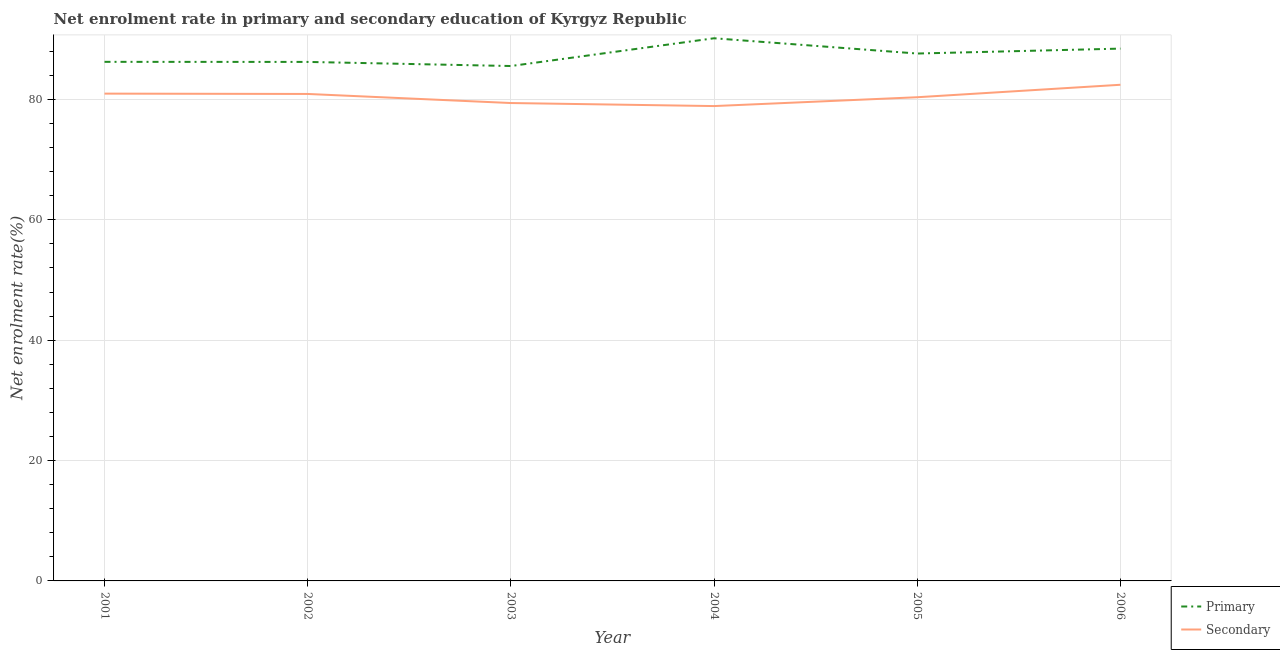Does the line corresponding to enrollment rate in primary education intersect with the line corresponding to enrollment rate in secondary education?
Your answer should be compact. No. What is the enrollment rate in secondary education in 2005?
Ensure brevity in your answer.  80.37. Across all years, what is the maximum enrollment rate in primary education?
Your response must be concise. 90.17. Across all years, what is the minimum enrollment rate in primary education?
Offer a terse response. 85.56. In which year was the enrollment rate in primary education maximum?
Make the answer very short. 2004. What is the total enrollment rate in primary education in the graph?
Give a very brief answer. 524.32. What is the difference between the enrollment rate in secondary education in 2001 and that in 2004?
Your answer should be compact. 2.07. What is the difference between the enrollment rate in secondary education in 2004 and the enrollment rate in primary education in 2003?
Your response must be concise. -6.65. What is the average enrollment rate in primary education per year?
Give a very brief answer. 87.39. In the year 2001, what is the difference between the enrollment rate in primary education and enrollment rate in secondary education?
Ensure brevity in your answer.  5.28. What is the ratio of the enrollment rate in secondary education in 2002 to that in 2003?
Your answer should be very brief. 1.02. What is the difference between the highest and the second highest enrollment rate in secondary education?
Provide a succinct answer. 1.47. What is the difference between the highest and the lowest enrollment rate in secondary education?
Your answer should be compact. 3.54. How many lines are there?
Provide a short and direct response. 2. Does the graph contain grids?
Keep it short and to the point. Yes. How many legend labels are there?
Provide a succinct answer. 2. How are the legend labels stacked?
Ensure brevity in your answer.  Vertical. What is the title of the graph?
Your response must be concise. Net enrolment rate in primary and secondary education of Kyrgyz Republic. Does "Mineral" appear as one of the legend labels in the graph?
Provide a short and direct response. No. What is the label or title of the X-axis?
Offer a terse response. Year. What is the label or title of the Y-axis?
Ensure brevity in your answer.  Net enrolment rate(%). What is the Net enrolment rate(%) in Primary in 2001?
Your answer should be compact. 86.25. What is the Net enrolment rate(%) in Secondary in 2001?
Ensure brevity in your answer.  80.97. What is the Net enrolment rate(%) in Primary in 2002?
Your answer should be compact. 86.24. What is the Net enrolment rate(%) in Secondary in 2002?
Ensure brevity in your answer.  80.92. What is the Net enrolment rate(%) of Primary in 2003?
Provide a short and direct response. 85.56. What is the Net enrolment rate(%) in Secondary in 2003?
Ensure brevity in your answer.  79.41. What is the Net enrolment rate(%) of Primary in 2004?
Provide a short and direct response. 90.17. What is the Net enrolment rate(%) of Secondary in 2004?
Keep it short and to the point. 78.91. What is the Net enrolment rate(%) in Primary in 2005?
Provide a short and direct response. 87.64. What is the Net enrolment rate(%) in Secondary in 2005?
Keep it short and to the point. 80.37. What is the Net enrolment rate(%) in Primary in 2006?
Your answer should be compact. 88.45. What is the Net enrolment rate(%) in Secondary in 2006?
Offer a very short reply. 82.45. Across all years, what is the maximum Net enrolment rate(%) in Primary?
Your response must be concise. 90.17. Across all years, what is the maximum Net enrolment rate(%) in Secondary?
Your answer should be compact. 82.45. Across all years, what is the minimum Net enrolment rate(%) of Primary?
Make the answer very short. 85.56. Across all years, what is the minimum Net enrolment rate(%) in Secondary?
Make the answer very short. 78.91. What is the total Net enrolment rate(%) in Primary in the graph?
Make the answer very short. 524.32. What is the total Net enrolment rate(%) in Secondary in the graph?
Make the answer very short. 483.03. What is the difference between the Net enrolment rate(%) in Primary in 2001 and that in 2002?
Provide a succinct answer. 0.01. What is the difference between the Net enrolment rate(%) in Secondary in 2001 and that in 2002?
Offer a terse response. 0.05. What is the difference between the Net enrolment rate(%) in Primary in 2001 and that in 2003?
Keep it short and to the point. 0.7. What is the difference between the Net enrolment rate(%) of Secondary in 2001 and that in 2003?
Your response must be concise. 1.56. What is the difference between the Net enrolment rate(%) of Primary in 2001 and that in 2004?
Keep it short and to the point. -3.92. What is the difference between the Net enrolment rate(%) in Secondary in 2001 and that in 2004?
Offer a very short reply. 2.07. What is the difference between the Net enrolment rate(%) of Primary in 2001 and that in 2005?
Offer a terse response. -1.38. What is the difference between the Net enrolment rate(%) in Secondary in 2001 and that in 2005?
Offer a very short reply. 0.6. What is the difference between the Net enrolment rate(%) of Primary in 2001 and that in 2006?
Offer a very short reply. -2.2. What is the difference between the Net enrolment rate(%) in Secondary in 2001 and that in 2006?
Your answer should be very brief. -1.47. What is the difference between the Net enrolment rate(%) of Primary in 2002 and that in 2003?
Keep it short and to the point. 0.68. What is the difference between the Net enrolment rate(%) in Secondary in 2002 and that in 2003?
Your answer should be compact. 1.51. What is the difference between the Net enrolment rate(%) of Primary in 2002 and that in 2004?
Give a very brief answer. -3.93. What is the difference between the Net enrolment rate(%) in Secondary in 2002 and that in 2004?
Ensure brevity in your answer.  2.01. What is the difference between the Net enrolment rate(%) in Primary in 2002 and that in 2005?
Offer a very short reply. -1.39. What is the difference between the Net enrolment rate(%) of Secondary in 2002 and that in 2005?
Your answer should be very brief. 0.55. What is the difference between the Net enrolment rate(%) of Primary in 2002 and that in 2006?
Provide a succinct answer. -2.21. What is the difference between the Net enrolment rate(%) of Secondary in 2002 and that in 2006?
Give a very brief answer. -1.53. What is the difference between the Net enrolment rate(%) in Primary in 2003 and that in 2004?
Provide a succinct answer. -4.61. What is the difference between the Net enrolment rate(%) in Secondary in 2003 and that in 2004?
Ensure brevity in your answer.  0.51. What is the difference between the Net enrolment rate(%) of Primary in 2003 and that in 2005?
Offer a terse response. -2.08. What is the difference between the Net enrolment rate(%) in Secondary in 2003 and that in 2005?
Ensure brevity in your answer.  -0.96. What is the difference between the Net enrolment rate(%) of Primary in 2003 and that in 2006?
Your response must be concise. -2.89. What is the difference between the Net enrolment rate(%) of Secondary in 2003 and that in 2006?
Keep it short and to the point. -3.04. What is the difference between the Net enrolment rate(%) of Primary in 2004 and that in 2005?
Keep it short and to the point. 2.54. What is the difference between the Net enrolment rate(%) in Secondary in 2004 and that in 2005?
Keep it short and to the point. -1.47. What is the difference between the Net enrolment rate(%) of Primary in 2004 and that in 2006?
Your answer should be very brief. 1.72. What is the difference between the Net enrolment rate(%) in Secondary in 2004 and that in 2006?
Make the answer very short. -3.54. What is the difference between the Net enrolment rate(%) of Primary in 2005 and that in 2006?
Your answer should be compact. -0.82. What is the difference between the Net enrolment rate(%) in Secondary in 2005 and that in 2006?
Your answer should be compact. -2.07. What is the difference between the Net enrolment rate(%) in Primary in 2001 and the Net enrolment rate(%) in Secondary in 2002?
Offer a terse response. 5.34. What is the difference between the Net enrolment rate(%) of Primary in 2001 and the Net enrolment rate(%) of Secondary in 2003?
Give a very brief answer. 6.84. What is the difference between the Net enrolment rate(%) in Primary in 2001 and the Net enrolment rate(%) in Secondary in 2004?
Provide a succinct answer. 7.35. What is the difference between the Net enrolment rate(%) of Primary in 2001 and the Net enrolment rate(%) of Secondary in 2005?
Ensure brevity in your answer.  5.88. What is the difference between the Net enrolment rate(%) of Primary in 2001 and the Net enrolment rate(%) of Secondary in 2006?
Keep it short and to the point. 3.81. What is the difference between the Net enrolment rate(%) of Primary in 2002 and the Net enrolment rate(%) of Secondary in 2003?
Give a very brief answer. 6.83. What is the difference between the Net enrolment rate(%) in Primary in 2002 and the Net enrolment rate(%) in Secondary in 2004?
Provide a short and direct response. 7.34. What is the difference between the Net enrolment rate(%) of Primary in 2002 and the Net enrolment rate(%) of Secondary in 2005?
Provide a succinct answer. 5.87. What is the difference between the Net enrolment rate(%) in Primary in 2002 and the Net enrolment rate(%) in Secondary in 2006?
Provide a succinct answer. 3.8. What is the difference between the Net enrolment rate(%) of Primary in 2003 and the Net enrolment rate(%) of Secondary in 2004?
Provide a succinct answer. 6.65. What is the difference between the Net enrolment rate(%) in Primary in 2003 and the Net enrolment rate(%) in Secondary in 2005?
Provide a short and direct response. 5.19. What is the difference between the Net enrolment rate(%) in Primary in 2003 and the Net enrolment rate(%) in Secondary in 2006?
Offer a terse response. 3.11. What is the difference between the Net enrolment rate(%) in Primary in 2004 and the Net enrolment rate(%) in Secondary in 2005?
Provide a short and direct response. 9.8. What is the difference between the Net enrolment rate(%) of Primary in 2004 and the Net enrolment rate(%) of Secondary in 2006?
Give a very brief answer. 7.73. What is the difference between the Net enrolment rate(%) in Primary in 2005 and the Net enrolment rate(%) in Secondary in 2006?
Your answer should be compact. 5.19. What is the average Net enrolment rate(%) in Primary per year?
Keep it short and to the point. 87.39. What is the average Net enrolment rate(%) of Secondary per year?
Your response must be concise. 80.5. In the year 2001, what is the difference between the Net enrolment rate(%) in Primary and Net enrolment rate(%) in Secondary?
Your answer should be very brief. 5.28. In the year 2002, what is the difference between the Net enrolment rate(%) of Primary and Net enrolment rate(%) of Secondary?
Ensure brevity in your answer.  5.32. In the year 2003, what is the difference between the Net enrolment rate(%) of Primary and Net enrolment rate(%) of Secondary?
Give a very brief answer. 6.15. In the year 2004, what is the difference between the Net enrolment rate(%) in Primary and Net enrolment rate(%) in Secondary?
Give a very brief answer. 11.27. In the year 2005, what is the difference between the Net enrolment rate(%) in Primary and Net enrolment rate(%) in Secondary?
Offer a terse response. 7.26. In the year 2006, what is the difference between the Net enrolment rate(%) of Primary and Net enrolment rate(%) of Secondary?
Keep it short and to the point. 6.01. What is the ratio of the Net enrolment rate(%) of Secondary in 2001 to that in 2002?
Ensure brevity in your answer.  1. What is the ratio of the Net enrolment rate(%) in Secondary in 2001 to that in 2003?
Make the answer very short. 1.02. What is the ratio of the Net enrolment rate(%) in Primary in 2001 to that in 2004?
Offer a terse response. 0.96. What is the ratio of the Net enrolment rate(%) in Secondary in 2001 to that in 2004?
Keep it short and to the point. 1.03. What is the ratio of the Net enrolment rate(%) in Primary in 2001 to that in 2005?
Your answer should be compact. 0.98. What is the ratio of the Net enrolment rate(%) of Secondary in 2001 to that in 2005?
Keep it short and to the point. 1.01. What is the ratio of the Net enrolment rate(%) of Primary in 2001 to that in 2006?
Ensure brevity in your answer.  0.98. What is the ratio of the Net enrolment rate(%) of Secondary in 2001 to that in 2006?
Ensure brevity in your answer.  0.98. What is the ratio of the Net enrolment rate(%) in Primary in 2002 to that in 2003?
Offer a very short reply. 1.01. What is the ratio of the Net enrolment rate(%) in Secondary in 2002 to that in 2003?
Keep it short and to the point. 1.02. What is the ratio of the Net enrolment rate(%) of Primary in 2002 to that in 2004?
Your response must be concise. 0.96. What is the ratio of the Net enrolment rate(%) in Secondary in 2002 to that in 2004?
Provide a short and direct response. 1.03. What is the ratio of the Net enrolment rate(%) in Primary in 2002 to that in 2005?
Ensure brevity in your answer.  0.98. What is the ratio of the Net enrolment rate(%) of Secondary in 2002 to that in 2005?
Offer a terse response. 1.01. What is the ratio of the Net enrolment rate(%) in Primary in 2002 to that in 2006?
Your response must be concise. 0.97. What is the ratio of the Net enrolment rate(%) of Secondary in 2002 to that in 2006?
Offer a terse response. 0.98. What is the ratio of the Net enrolment rate(%) in Primary in 2003 to that in 2004?
Your answer should be very brief. 0.95. What is the ratio of the Net enrolment rate(%) of Secondary in 2003 to that in 2004?
Provide a succinct answer. 1.01. What is the ratio of the Net enrolment rate(%) of Primary in 2003 to that in 2005?
Make the answer very short. 0.98. What is the ratio of the Net enrolment rate(%) of Primary in 2003 to that in 2006?
Provide a short and direct response. 0.97. What is the ratio of the Net enrolment rate(%) in Secondary in 2003 to that in 2006?
Provide a short and direct response. 0.96. What is the ratio of the Net enrolment rate(%) of Primary in 2004 to that in 2005?
Offer a terse response. 1.03. What is the ratio of the Net enrolment rate(%) in Secondary in 2004 to that in 2005?
Your answer should be compact. 0.98. What is the ratio of the Net enrolment rate(%) in Primary in 2004 to that in 2006?
Keep it short and to the point. 1.02. What is the ratio of the Net enrolment rate(%) in Secondary in 2004 to that in 2006?
Provide a succinct answer. 0.96. What is the ratio of the Net enrolment rate(%) of Secondary in 2005 to that in 2006?
Offer a terse response. 0.97. What is the difference between the highest and the second highest Net enrolment rate(%) of Primary?
Keep it short and to the point. 1.72. What is the difference between the highest and the second highest Net enrolment rate(%) of Secondary?
Your answer should be very brief. 1.47. What is the difference between the highest and the lowest Net enrolment rate(%) in Primary?
Provide a short and direct response. 4.61. What is the difference between the highest and the lowest Net enrolment rate(%) of Secondary?
Offer a very short reply. 3.54. 